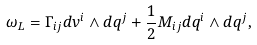<formula> <loc_0><loc_0><loc_500><loc_500>\omega _ { L } = \Gamma _ { i j } d v ^ { i } \wedge d q ^ { j } + \frac { 1 } { 2 } M _ { i j } d q ^ { i } \wedge d q ^ { j } ,</formula> 